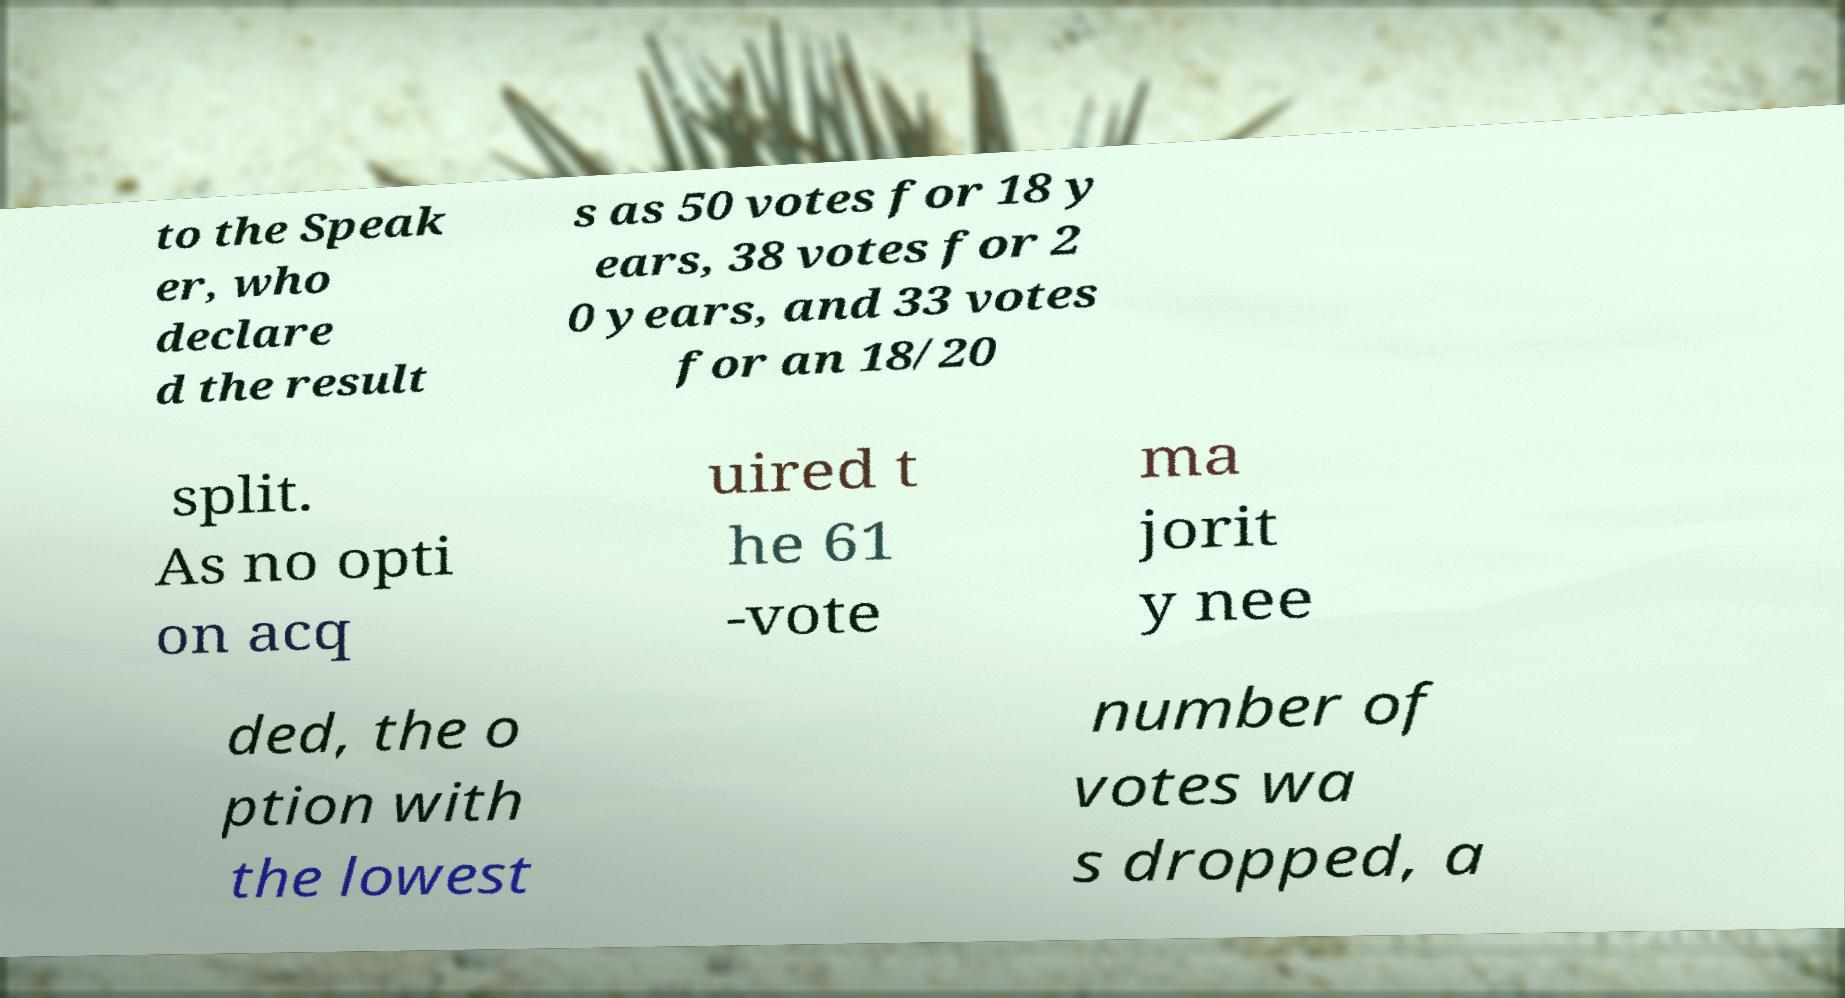Can you accurately transcribe the text from the provided image for me? to the Speak er, who declare d the result s as 50 votes for 18 y ears, 38 votes for 2 0 years, and 33 votes for an 18/20 split. As no opti on acq uired t he 61 -vote ma jorit y nee ded, the o ption with the lowest number of votes wa s dropped, a 